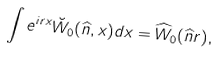Convert formula to latex. <formula><loc_0><loc_0><loc_500><loc_500>\int e ^ { i r x } \breve { W } _ { 0 } ( \widehat { n } , x ) d x = \widehat { W } _ { 0 } ( \widehat { n } r ) ,</formula> 